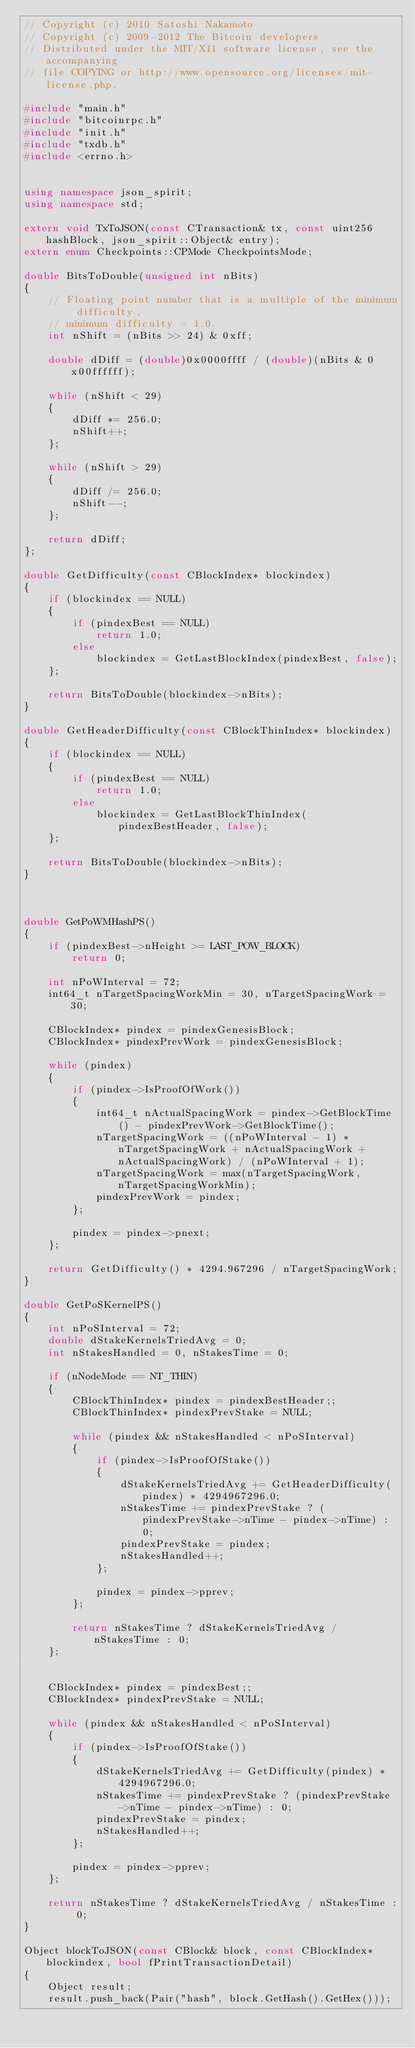Convert code to text. <code><loc_0><loc_0><loc_500><loc_500><_C++_>// Copyright (c) 2010 Satoshi Nakamoto
// Copyright (c) 2009-2012 The Bitcoin developers
// Distributed under the MIT/X11 software license, see the accompanying
// file COPYING or http://www.opensource.org/licenses/mit-license.php.

#include "main.h"
#include "bitcoinrpc.h"
#include "init.h"
#include "txdb.h"
#include <errno.h>


using namespace json_spirit;
using namespace std;

extern void TxToJSON(const CTransaction& tx, const uint256 hashBlock, json_spirit::Object& entry);
extern enum Checkpoints::CPMode CheckpointsMode;

double BitsToDouble(unsigned int nBits)
{
    // Floating point number that is a multiple of the minimum difficulty,
    // minimum difficulty = 1.0.
    int nShift = (nBits >> 24) & 0xff;

    double dDiff = (double)0x0000ffff / (double)(nBits & 0x00ffffff);

    while (nShift < 29)
    {
        dDiff *= 256.0;
        nShift++;
    };
    
    while (nShift > 29)
    {
        dDiff /= 256.0;
        nShift--;
    };

    return dDiff;
};

double GetDifficulty(const CBlockIndex* blockindex)
{
    if (blockindex == NULL)
    {
        if (pindexBest == NULL)
            return 1.0;
        else
            blockindex = GetLastBlockIndex(pindexBest, false);
    };

    return BitsToDouble(blockindex->nBits);
}

double GetHeaderDifficulty(const CBlockThinIndex* blockindex)
{
    if (blockindex == NULL)
    {
        if (pindexBest == NULL)
            return 1.0;
        else
            blockindex = GetLastBlockThinIndex(pindexBestHeader, false);
    };

    return BitsToDouble(blockindex->nBits);
}



double GetPoWMHashPS()
{
    if (pindexBest->nHeight >= LAST_POW_BLOCK)
        return 0;

    int nPoWInterval = 72;
    int64_t nTargetSpacingWorkMin = 30, nTargetSpacingWork = 30;

    CBlockIndex* pindex = pindexGenesisBlock;
    CBlockIndex* pindexPrevWork = pindexGenesisBlock;

    while (pindex)
    {
        if (pindex->IsProofOfWork())
        {
            int64_t nActualSpacingWork = pindex->GetBlockTime() - pindexPrevWork->GetBlockTime();
            nTargetSpacingWork = ((nPoWInterval - 1) * nTargetSpacingWork + nActualSpacingWork + nActualSpacingWork) / (nPoWInterval + 1);
            nTargetSpacingWork = max(nTargetSpacingWork, nTargetSpacingWorkMin);
            pindexPrevWork = pindex;
        };

        pindex = pindex->pnext;
    };

    return GetDifficulty() * 4294.967296 / nTargetSpacingWork;
}

double GetPoSKernelPS()
{
    int nPoSInterval = 72;
    double dStakeKernelsTriedAvg = 0;
    int nStakesHandled = 0, nStakesTime = 0;
    
    if (nNodeMode == NT_THIN)
    {
        CBlockThinIndex* pindex = pindexBestHeader;;
        CBlockThinIndex* pindexPrevStake = NULL;
        
        while (pindex && nStakesHandled < nPoSInterval)
        {
            if (pindex->IsProofOfStake())
            {
                dStakeKernelsTriedAvg += GetHeaderDifficulty(pindex) * 4294967296.0;
                nStakesTime += pindexPrevStake ? (pindexPrevStake->nTime - pindex->nTime) : 0;
                pindexPrevStake = pindex;
                nStakesHandled++;
            };

            pindex = pindex->pprev;
        };

        return nStakesTime ? dStakeKernelsTriedAvg / nStakesTime : 0;
    };
    
    
    CBlockIndex* pindex = pindexBest;;
    CBlockIndex* pindexPrevStake = NULL;

    while (pindex && nStakesHandled < nPoSInterval)
    {
        if (pindex->IsProofOfStake())
        {
            dStakeKernelsTriedAvg += GetDifficulty(pindex) * 4294967296.0;
            nStakesTime += pindexPrevStake ? (pindexPrevStake->nTime - pindex->nTime) : 0;
            pindexPrevStake = pindex;
            nStakesHandled++;
        };

        pindex = pindex->pprev;
    };

    return nStakesTime ? dStakeKernelsTriedAvg / nStakesTime : 0;
}

Object blockToJSON(const CBlock& block, const CBlockIndex* blockindex, bool fPrintTransactionDetail)
{
    Object result;
    result.push_back(Pair("hash", block.GetHash().GetHex()));</code> 